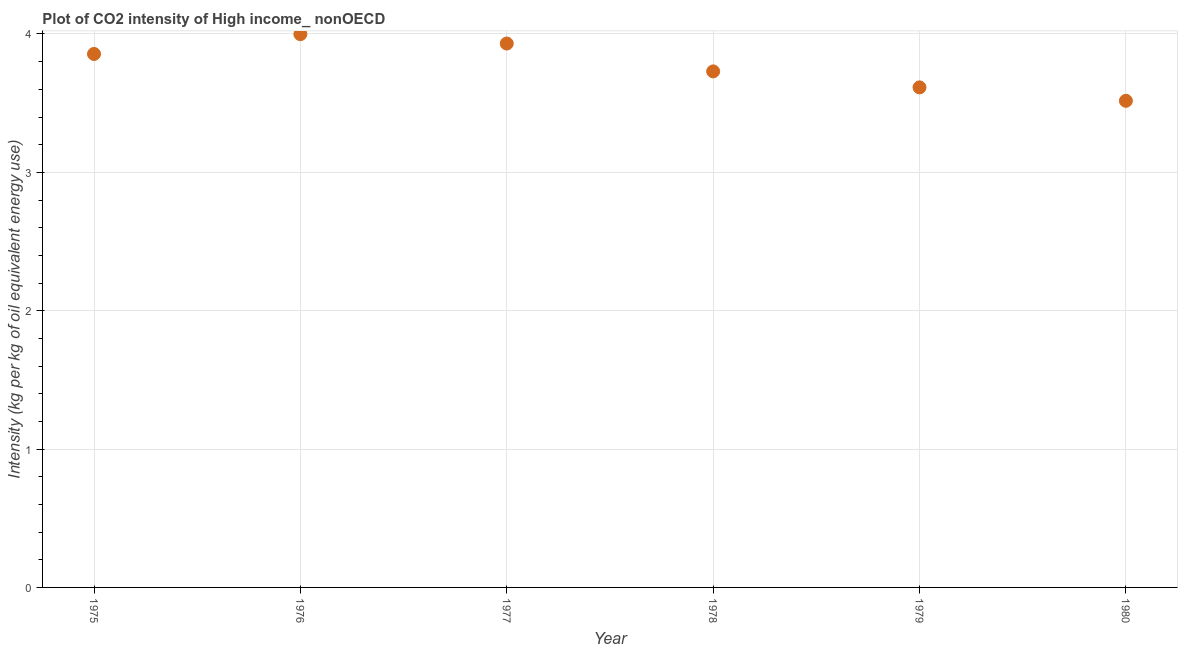What is the co2 intensity in 1980?
Your response must be concise. 3.52. Across all years, what is the maximum co2 intensity?
Your response must be concise. 4. Across all years, what is the minimum co2 intensity?
Offer a terse response. 3.52. In which year was the co2 intensity maximum?
Offer a very short reply. 1976. In which year was the co2 intensity minimum?
Give a very brief answer. 1980. What is the sum of the co2 intensity?
Make the answer very short. 22.65. What is the difference between the co2 intensity in 1976 and 1977?
Your answer should be compact. 0.07. What is the average co2 intensity per year?
Provide a succinct answer. 3.77. What is the median co2 intensity?
Make the answer very short. 3.79. In how many years, is the co2 intensity greater than 3.4 kg?
Your answer should be compact. 6. What is the ratio of the co2 intensity in 1975 to that in 1979?
Offer a terse response. 1.07. Is the co2 intensity in 1978 less than that in 1980?
Ensure brevity in your answer.  No. What is the difference between the highest and the second highest co2 intensity?
Provide a short and direct response. 0.07. Is the sum of the co2 intensity in 1977 and 1978 greater than the maximum co2 intensity across all years?
Offer a terse response. Yes. What is the difference between the highest and the lowest co2 intensity?
Your answer should be compact. 0.48. In how many years, is the co2 intensity greater than the average co2 intensity taken over all years?
Provide a short and direct response. 3. Are the values on the major ticks of Y-axis written in scientific E-notation?
Keep it short and to the point. No. What is the title of the graph?
Ensure brevity in your answer.  Plot of CO2 intensity of High income_ nonOECD. What is the label or title of the Y-axis?
Provide a short and direct response. Intensity (kg per kg of oil equivalent energy use). What is the Intensity (kg per kg of oil equivalent energy use) in 1975?
Offer a terse response. 3.86. What is the Intensity (kg per kg of oil equivalent energy use) in 1976?
Provide a succinct answer. 4. What is the Intensity (kg per kg of oil equivalent energy use) in 1977?
Your answer should be compact. 3.93. What is the Intensity (kg per kg of oil equivalent energy use) in 1978?
Your answer should be compact. 3.73. What is the Intensity (kg per kg of oil equivalent energy use) in 1979?
Provide a short and direct response. 3.61. What is the Intensity (kg per kg of oil equivalent energy use) in 1980?
Keep it short and to the point. 3.52. What is the difference between the Intensity (kg per kg of oil equivalent energy use) in 1975 and 1976?
Your answer should be compact. -0.14. What is the difference between the Intensity (kg per kg of oil equivalent energy use) in 1975 and 1977?
Your answer should be compact. -0.08. What is the difference between the Intensity (kg per kg of oil equivalent energy use) in 1975 and 1978?
Keep it short and to the point. 0.13. What is the difference between the Intensity (kg per kg of oil equivalent energy use) in 1975 and 1979?
Your response must be concise. 0.24. What is the difference between the Intensity (kg per kg of oil equivalent energy use) in 1975 and 1980?
Your answer should be very brief. 0.34. What is the difference between the Intensity (kg per kg of oil equivalent energy use) in 1976 and 1977?
Your answer should be compact. 0.07. What is the difference between the Intensity (kg per kg of oil equivalent energy use) in 1976 and 1978?
Give a very brief answer. 0.27. What is the difference between the Intensity (kg per kg of oil equivalent energy use) in 1976 and 1979?
Provide a short and direct response. 0.38. What is the difference between the Intensity (kg per kg of oil equivalent energy use) in 1976 and 1980?
Your response must be concise. 0.48. What is the difference between the Intensity (kg per kg of oil equivalent energy use) in 1977 and 1978?
Your answer should be very brief. 0.2. What is the difference between the Intensity (kg per kg of oil equivalent energy use) in 1977 and 1979?
Your response must be concise. 0.32. What is the difference between the Intensity (kg per kg of oil equivalent energy use) in 1977 and 1980?
Make the answer very short. 0.41. What is the difference between the Intensity (kg per kg of oil equivalent energy use) in 1978 and 1979?
Offer a terse response. 0.12. What is the difference between the Intensity (kg per kg of oil equivalent energy use) in 1978 and 1980?
Give a very brief answer. 0.21. What is the difference between the Intensity (kg per kg of oil equivalent energy use) in 1979 and 1980?
Keep it short and to the point. 0.1. What is the ratio of the Intensity (kg per kg of oil equivalent energy use) in 1975 to that in 1978?
Provide a succinct answer. 1.03. What is the ratio of the Intensity (kg per kg of oil equivalent energy use) in 1975 to that in 1979?
Make the answer very short. 1.07. What is the ratio of the Intensity (kg per kg of oil equivalent energy use) in 1975 to that in 1980?
Give a very brief answer. 1.1. What is the ratio of the Intensity (kg per kg of oil equivalent energy use) in 1976 to that in 1977?
Keep it short and to the point. 1.02. What is the ratio of the Intensity (kg per kg of oil equivalent energy use) in 1976 to that in 1978?
Ensure brevity in your answer.  1.07. What is the ratio of the Intensity (kg per kg of oil equivalent energy use) in 1976 to that in 1979?
Your answer should be compact. 1.11. What is the ratio of the Intensity (kg per kg of oil equivalent energy use) in 1976 to that in 1980?
Give a very brief answer. 1.14. What is the ratio of the Intensity (kg per kg of oil equivalent energy use) in 1977 to that in 1978?
Provide a succinct answer. 1.05. What is the ratio of the Intensity (kg per kg of oil equivalent energy use) in 1977 to that in 1979?
Ensure brevity in your answer.  1.09. What is the ratio of the Intensity (kg per kg of oil equivalent energy use) in 1977 to that in 1980?
Offer a very short reply. 1.12. What is the ratio of the Intensity (kg per kg of oil equivalent energy use) in 1978 to that in 1979?
Provide a short and direct response. 1.03. What is the ratio of the Intensity (kg per kg of oil equivalent energy use) in 1978 to that in 1980?
Ensure brevity in your answer.  1.06. What is the ratio of the Intensity (kg per kg of oil equivalent energy use) in 1979 to that in 1980?
Make the answer very short. 1.03. 